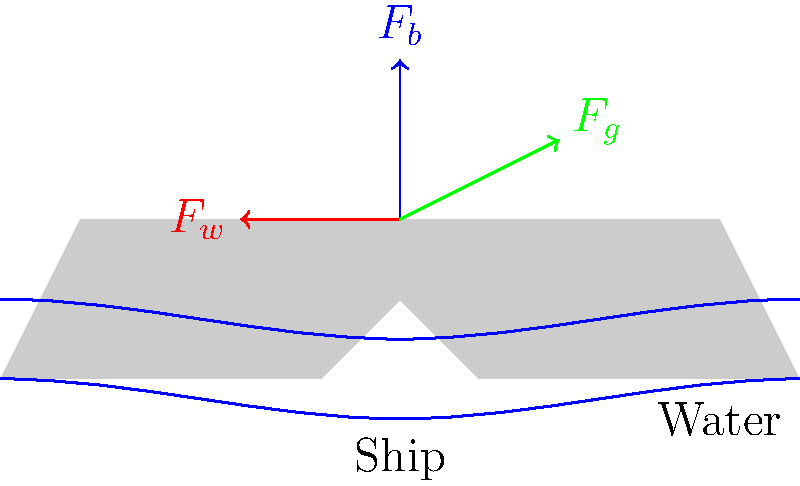A traditional New England wooden ship is sailing through rough seas. The diagram shows three main forces acting on the ship: buoyancy ($F_b$), wind ($F_w$), and gravity ($F_g$). If the ship maintains a steady position without sinking or rising, what can you conclude about these forces? To solve this problem, let's follow these steps:

1. Identify the forces:
   $F_b$: Buoyancy force (upward)
   $F_w$: Wind force (horizontal)
   $F_g$: Gravitational force (downward)

2. Recall Newton's First Law of Motion:
   An object at rest stays at rest, and an object in motion stays in motion with the same speed and in the same direction unless acted upon by an unbalanced force.

3. Apply this law to our scenario:
   If the ship maintains a steady position (not sinking or rising), it means the ship is in equilibrium.

4. For equilibrium in the vertical direction:
   The upward force must equal the downward force.
   $F_b = F_g$

5. For equilibrium in the horizontal direction:
   There must be an opposing force to the wind force $F_w$. This is likely the resistance of the water, which isn't shown in the diagram but is implied.

6. Vector sum:
   For the ship to be in equilibrium, the vector sum of all forces must be zero.
   $\vec{F_b} + \vec{F_w} + \vec{F_g} + \vec{F_{\text{water resistance}}} = 0$

Therefore, we can conclude that all forces acting on the ship are in balance, with the buoyancy force equal in magnitude to the gravitational force, and the wind force balanced by the water resistance.
Answer: Forces are balanced: $F_b = F_g$, $F_w$ balanced by water resistance. 